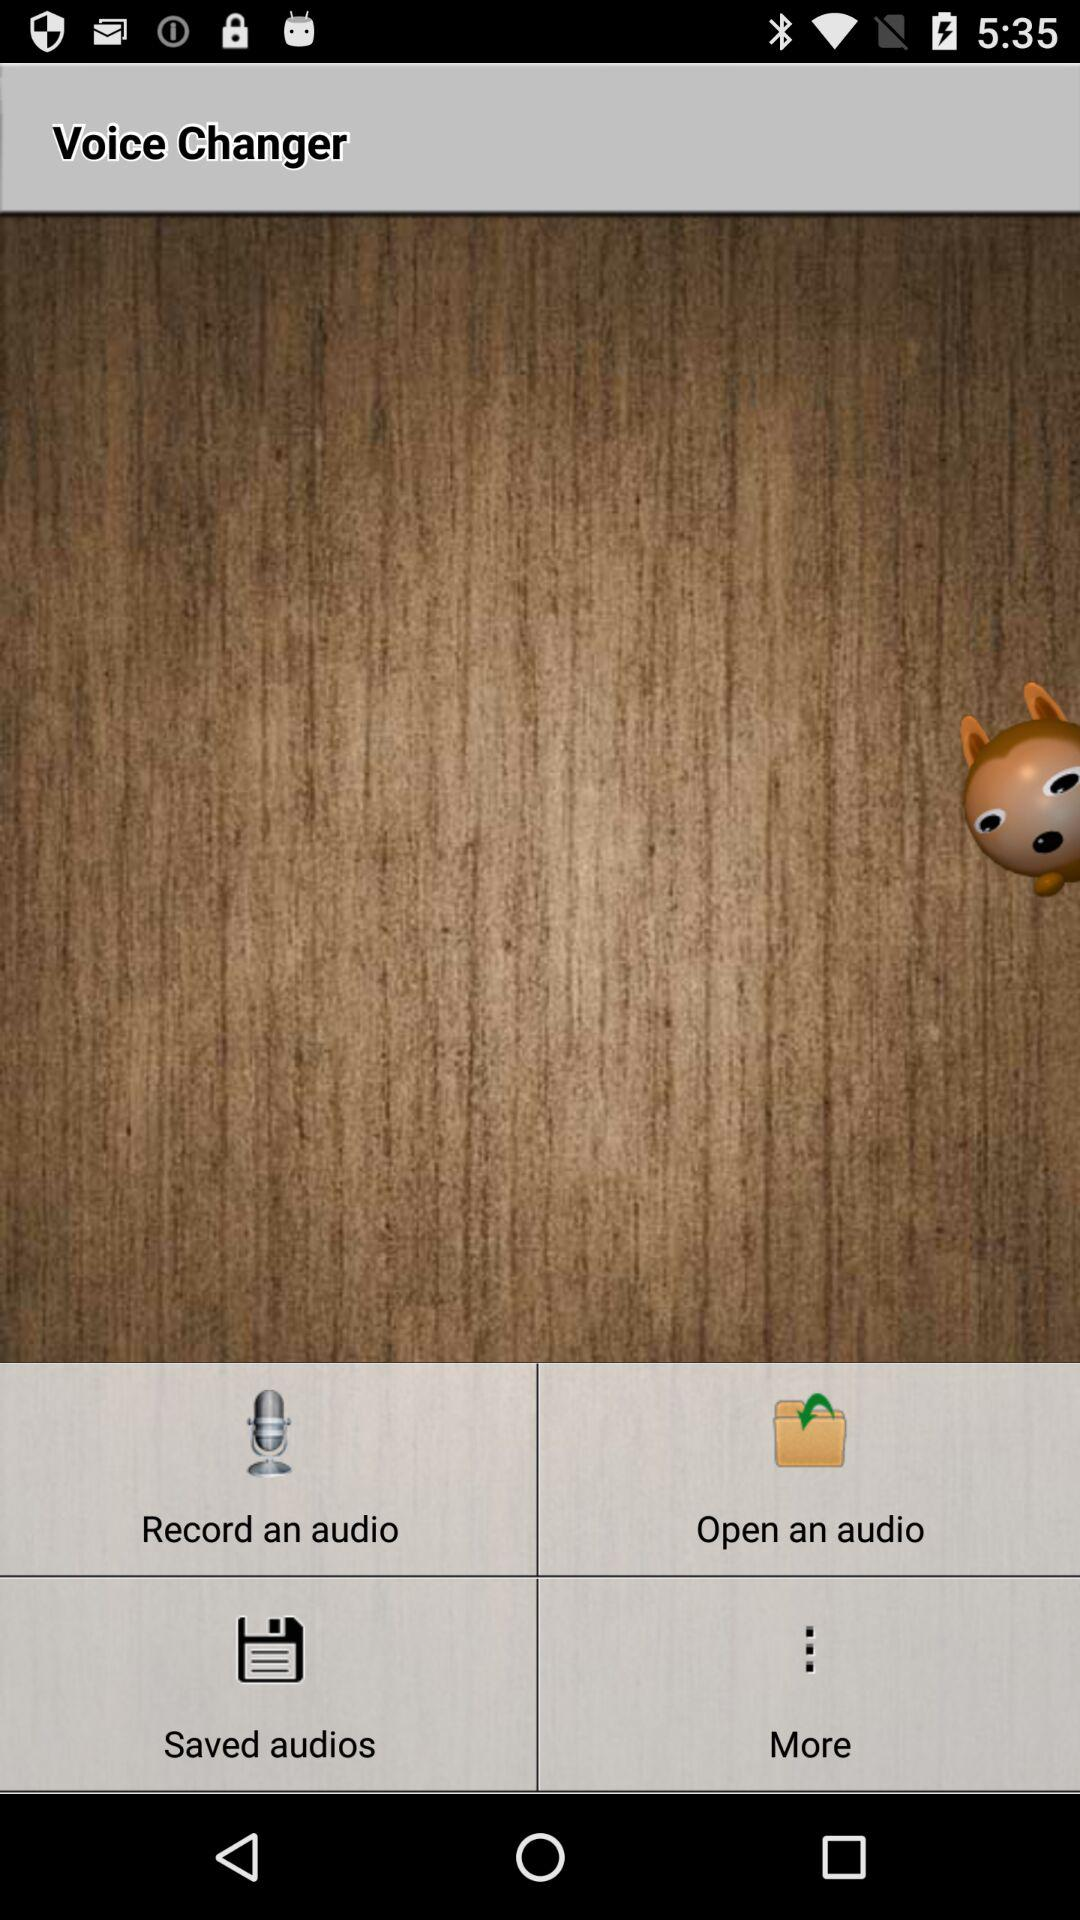What is the name of the application? The name of the application is "Voice Changer". 